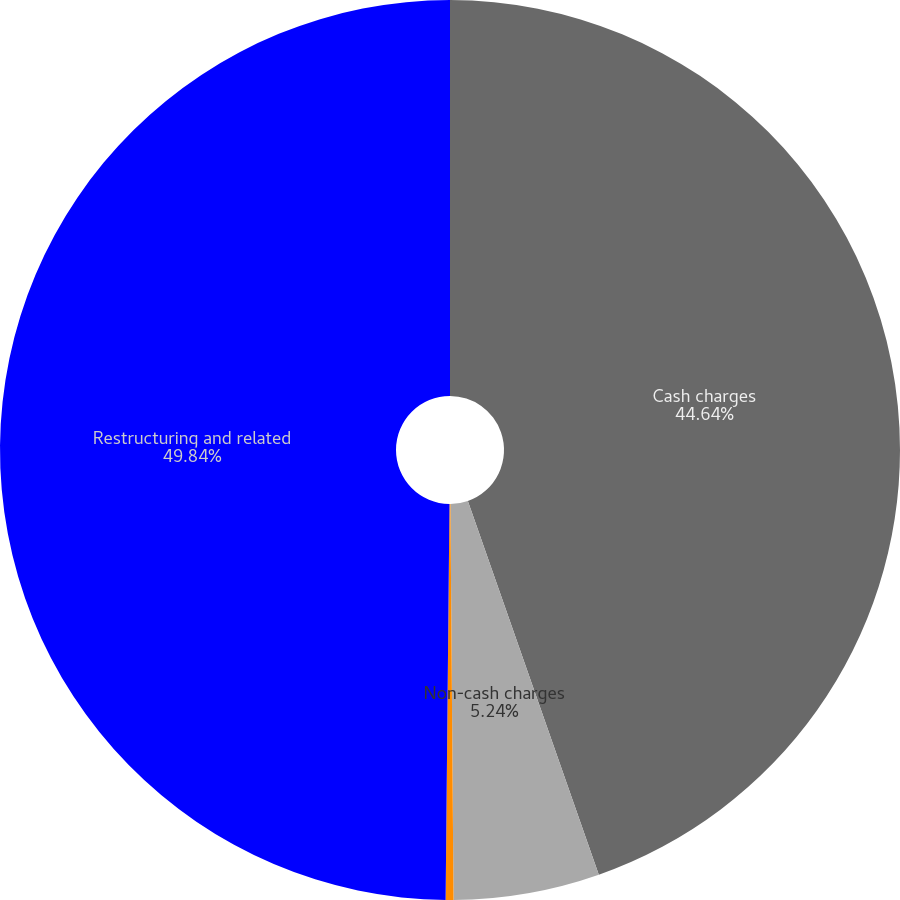Convert chart to OTSL. <chart><loc_0><loc_0><loc_500><loc_500><pie_chart><fcel>Cash charges<fcel>Non-cash charges<fcel>Less (charges) credits in cost<fcel>Restructuring and related<nl><fcel>44.64%<fcel>5.24%<fcel>0.28%<fcel>49.85%<nl></chart> 